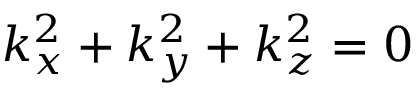<formula> <loc_0><loc_0><loc_500><loc_500>k _ { x } ^ { 2 } + k _ { y } ^ { 2 } + k _ { z } ^ { 2 } = 0</formula> 